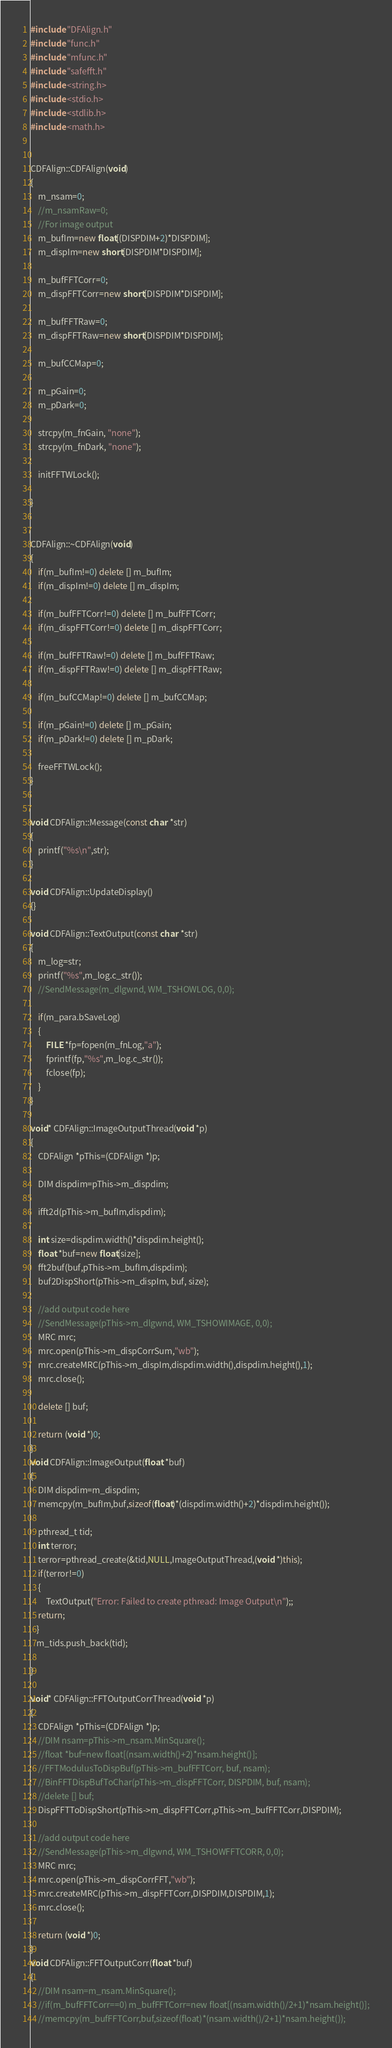Convert code to text. <code><loc_0><loc_0><loc_500><loc_500><_C++_>#include "DFAlign.h"
#include "func.h"
#include "mfunc.h"
#include "safefft.h"
#include <string.h>
#include <stdio.h>
#include <stdlib.h>
#include <math.h>


CDFAlign::CDFAlign(void)
{
	m_nsam=0;
	//m_nsamRaw=0;
	//For image output
	m_bufIm=new float[(DISPDIM+2)*DISPDIM];
	m_dispIm=new short[DISPDIM*DISPDIM];

	m_bufFFTCorr=0;
	m_dispFFTCorr=new short[DISPDIM*DISPDIM];

	m_bufFFTRaw=0;
	m_dispFFTRaw=new short[DISPDIM*DISPDIM];

	m_bufCCMap=0;

	m_pGain=0;
	m_pDark=0;

	strcpy(m_fnGain, "none");
	strcpy(m_fnDark, "none");

	initFFTWLock();

}


CDFAlign::~CDFAlign(void)
{
	if(m_bufIm!=0) delete [] m_bufIm;
	if(m_dispIm!=0) delete [] m_dispIm;

	if(m_bufFFTCorr!=0) delete [] m_bufFFTCorr;
	if(m_dispFFTCorr!=0) delete [] m_dispFFTCorr;

	if(m_bufFFTRaw!=0) delete [] m_bufFFTRaw;
	if(m_dispFFTRaw!=0) delete [] m_dispFFTRaw;

	if(m_bufCCMap!=0) delete [] m_bufCCMap;

	if(m_pGain!=0) delete [] m_pGain;
	if(m_pDark!=0) delete [] m_pDark;

	freeFFTWLock();
}


void CDFAlign::Message(const char *str)
{
	printf("%s\n",str);
}

void CDFAlign::UpdateDisplay()
{}

void CDFAlign::TextOutput(const char *str)
{
	m_log=str;
	printf("%s",m_log.c_str());
	//SendMessage(m_dlgwnd, WM_TSHOWLOG, 0,0);

	if(m_para.bSaveLog)
	{
		FILE *fp=fopen(m_fnLog,"a");
		fprintf(fp,"%s",m_log.c_str());
		fclose(fp);
	}
}

void* CDFAlign::ImageOutputThread(void *p)
{
	CDFAlign *pThis=(CDFAlign *)p;

	DIM dispdim=pThis->m_dispdim;

	ifft2d(pThis->m_bufIm,dispdim);

	int size=dispdim.width()*dispdim.height();
	float *buf=new float[size];
	fft2buf(buf,pThis->m_bufIm,dispdim);
	buf2DispShort(pThis->m_dispIm, buf, size);

	//add output code here
	//SendMessage(pThis->m_dlgwnd, WM_TSHOWIMAGE, 0,0);
	MRC mrc;
	mrc.open(pThis->m_dispCorrSum,"wb");
	mrc.createMRC(pThis->m_dispIm,dispdim.width(),dispdim.height(),1);
	mrc.close();

	delete [] buf;

	return (void *)0;
}
void CDFAlign::ImageOutput(float *buf)
{
	DIM dispdim=m_dispdim;
	memcpy(m_bufIm,buf,sizeof(float)*(dispdim.width()+2)*dispdim.height());

	pthread_t tid;
	int terror;
	terror=pthread_create(&tid,NULL,ImageOutputThread,(void *)this);
  	if(terror!=0)
  	{
		TextOutput("Error: Failed to create pthread: Image Output\n");;
   	return;
   }
   m_tids.push_back(tid);

}

void* CDFAlign::FFTOutputCorrThread(void *p)
{
	CDFAlign *pThis=(CDFAlign *)p;
	//DIM nsam=pThis->m_nsam.MinSquare();
	//float *buf=new float[(nsam.width()+2)*nsam.height()];
	//FFTModulusToDispBuf(pThis->m_bufFFTCorr, buf, nsam);
	//BinFFTDispBufToChar(pThis->m_dispFFTCorr, DISPDIM, buf, nsam);
	//delete [] buf;
	DispFFTToDispShort(pThis->m_dispFFTCorr,pThis->m_bufFFTCorr,DISPDIM);

	//add output code here
	//SendMessage(pThis->m_dlgwnd, WM_TSHOWFFTCORR, 0,0);
	MRC mrc;
	mrc.open(pThis->m_dispCorrFFT,"wb");
	mrc.createMRC(pThis->m_dispFFTCorr,DISPDIM,DISPDIM,1);
	mrc.close();

	return (void *)0;
}
void CDFAlign::FFTOutputCorr(float *buf)
{
	//DIM nsam=m_nsam.MinSquare();
	//if(m_bufFFTCorr==0) m_bufFFTCorr=new float[(nsam.width()/2+1)*nsam.height()];
	//memcpy(m_bufFFTCorr,buf,sizeof(float)*(nsam.width()/2+1)*nsam.height());</code> 